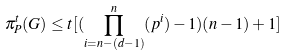Convert formula to latex. <formula><loc_0><loc_0><loc_500><loc_500>\pi _ { P } ^ { t } ( G ) \leq t [ ( \prod _ { i = n - ( d - 1 ) } ^ { n } ( p ^ { i } ) - 1 ) ( n - 1 ) + 1 ]</formula> 